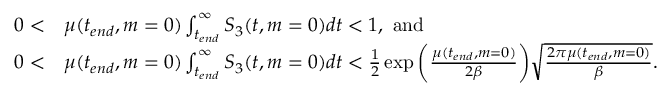<formula> <loc_0><loc_0><loc_500><loc_500>\begin{array} { r l } { 0 < } & { \mu ( t _ { e n d } , m = 0 ) \int _ { t _ { e n d } } ^ { \infty } S _ { 3 } ( t , m = 0 ) d t < 1 , a n d } \\ { 0 < } & { \mu ( t _ { e n d } , m = 0 ) \int _ { t _ { e n d } } ^ { \infty } S _ { 3 } ( t , m = 0 ) d t < \frac { 1 } { 2 } \exp { \left ( \frac { \mu ( t _ { e n d } , m = 0 ) } { 2 \beta } \right ) } \sqrt { \frac { 2 \pi \mu ( t _ { e n d } , m = 0 ) } { \beta } } . } \end{array}</formula> 